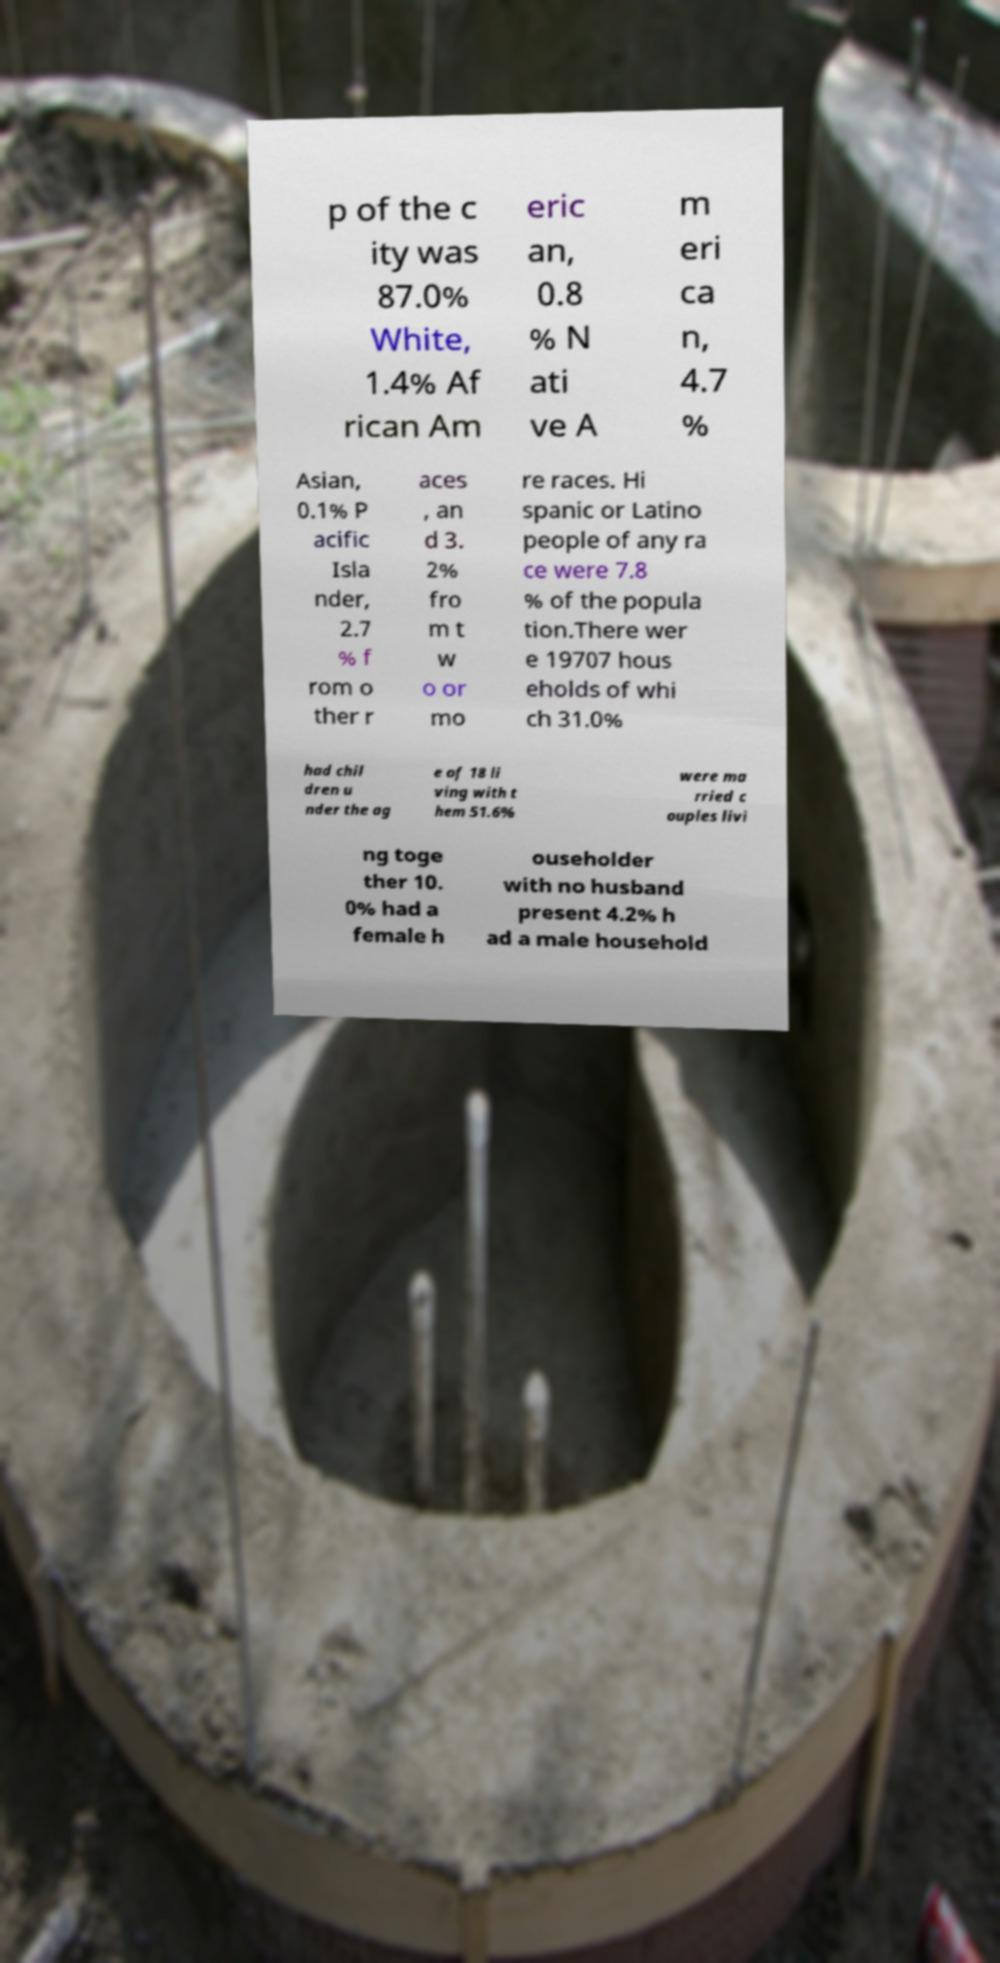Please read and relay the text visible in this image. What does it say? p of the c ity was 87.0% White, 1.4% Af rican Am eric an, 0.8 % N ati ve A m eri ca n, 4.7 % Asian, 0.1% P acific Isla nder, 2.7 % f rom o ther r aces , an d 3. 2% fro m t w o or mo re races. Hi spanic or Latino people of any ra ce were 7.8 % of the popula tion.There wer e 19707 hous eholds of whi ch 31.0% had chil dren u nder the ag e of 18 li ving with t hem 51.6% were ma rried c ouples livi ng toge ther 10. 0% had a female h ouseholder with no husband present 4.2% h ad a male household 